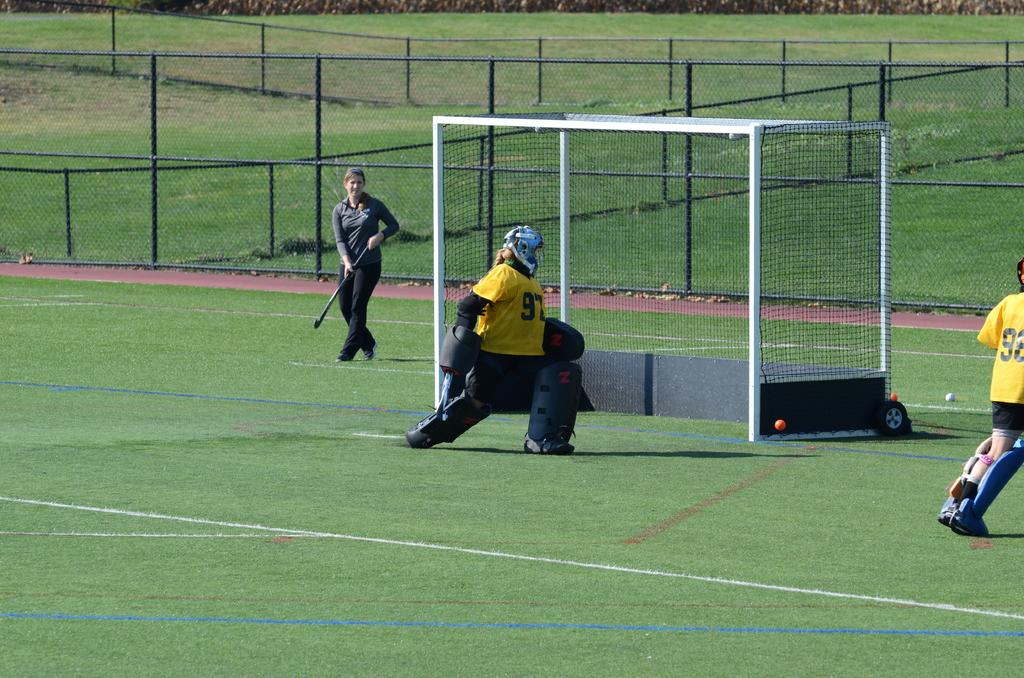<image>
Relay a brief, clear account of the picture shown. A field hockey goalie in a yellow jersey with the number 97 on it. 